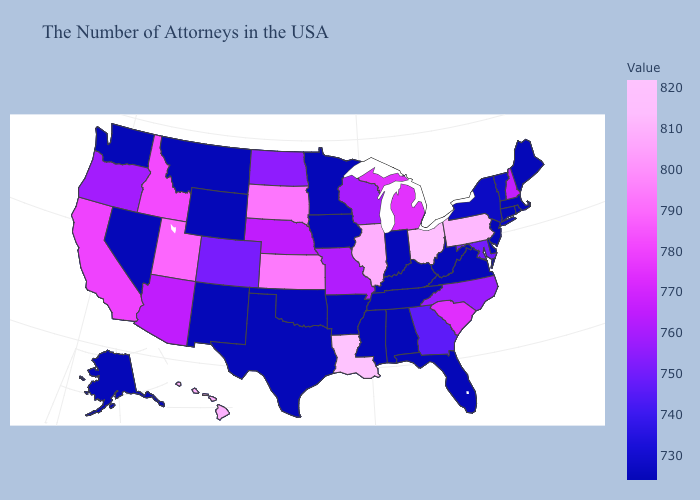Among the states that border South Carolina , which have the highest value?
Concise answer only. North Carolina. Does the map have missing data?
Answer briefly. No. Among the states that border Oklahoma , does Kansas have the lowest value?
Quick response, please. No. 